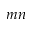Convert formula to latex. <formula><loc_0><loc_0><loc_500><loc_500>m n</formula> 